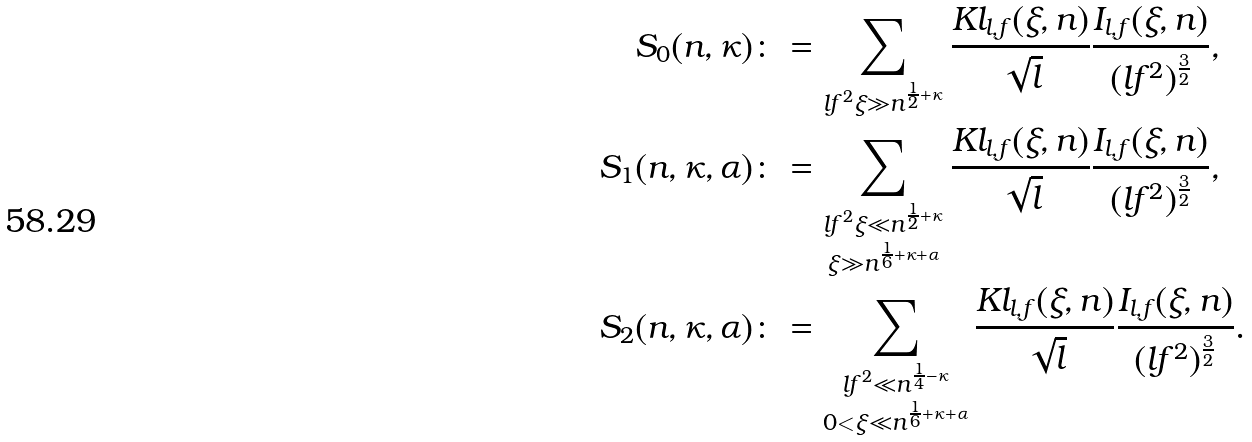<formula> <loc_0><loc_0><loc_500><loc_500>S _ { 0 } ( n , \kappa ) & \colon = \sum _ { \substack { l f ^ { 2 } \xi \gg n ^ { \frac { 1 } { 2 } + \kappa } } } \frac { K l _ { l , f } ( \xi , n ) } { \sqrt { l } } \frac { I _ { l , f } ( \xi , n ) } { ( l f ^ { 2 } ) ^ { \frac { 3 } { 2 } } } , \\ S _ { 1 } ( n , \kappa , \alpha ) & \colon = \sum _ { \substack { l f ^ { 2 } \xi \ll n ^ { \frac { 1 } { 2 } + \kappa } \\ \xi \gg n ^ { \frac { 1 } { 6 } + \kappa + \alpha } } } \frac { K l _ { l , f } ( \xi , n ) } { \sqrt { l } } \frac { I _ { l , f } ( \xi , n ) } { ( l f ^ { 2 } ) ^ { \frac { 3 } { 2 } } } , \\ S _ { 2 } ( n , \kappa , \alpha ) & \colon = \sum _ { \substack { l f ^ { 2 } \ll n ^ { \frac { 1 } { 4 } - \kappa } \\ 0 < \xi \ll n ^ { \frac { 1 } { 6 } + \kappa + \alpha } } } \frac { K l _ { l , f } ( \xi , n ) } { \sqrt { l } } \frac { I _ { l , f } ( \xi , n ) } { ( l f ^ { 2 } ) ^ { \frac { 3 } { 2 } } } .</formula> 